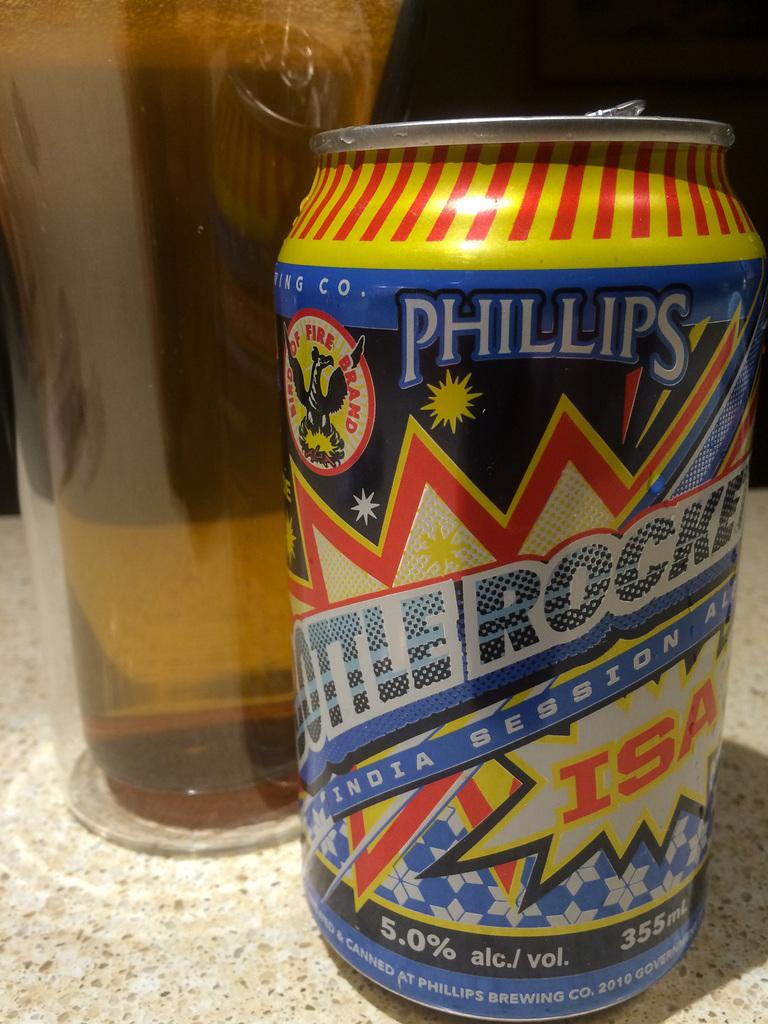Provide a one-sentence caption for the provided image. A can of Phillips Bottle Rocket contains 355 mL. 